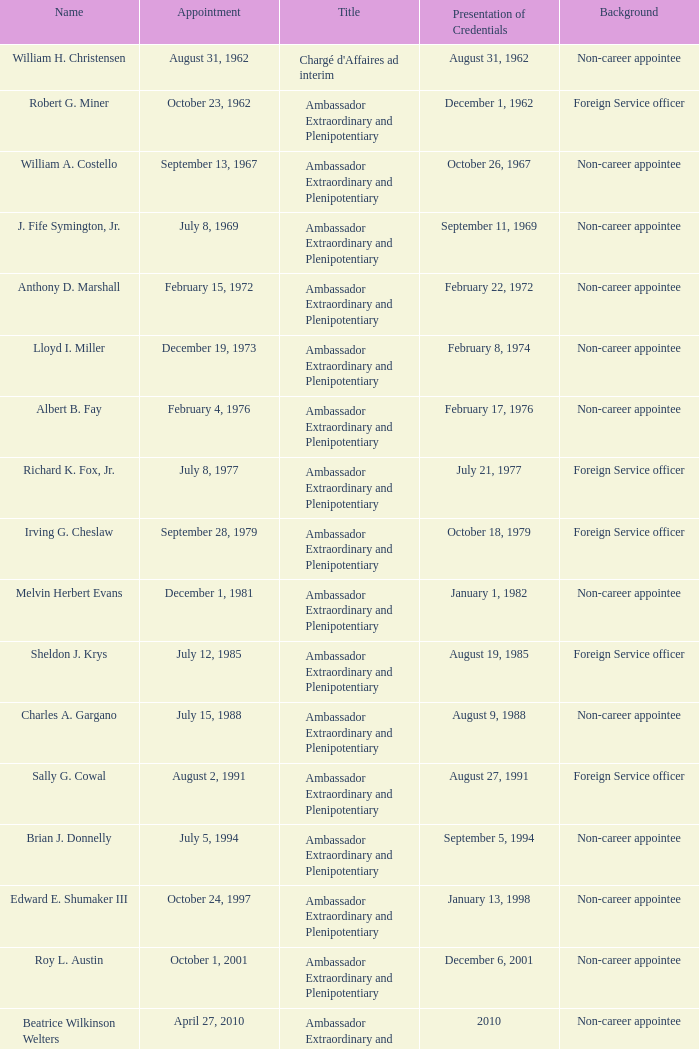What was Anthony D. Marshall's title? Ambassador Extraordinary and Plenipotentiary. 